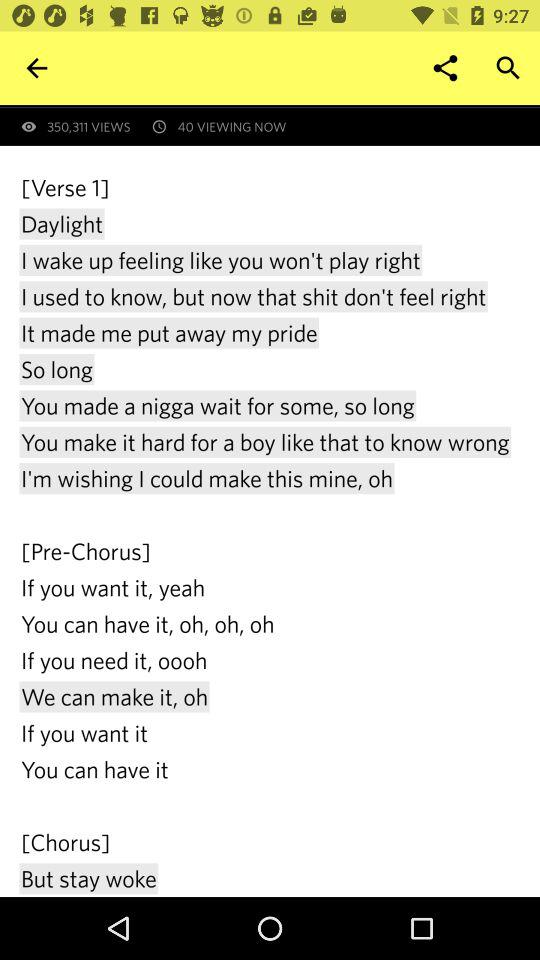When was this song first published?
When the provided information is insufficient, respond with <no answer>. <no answer> 